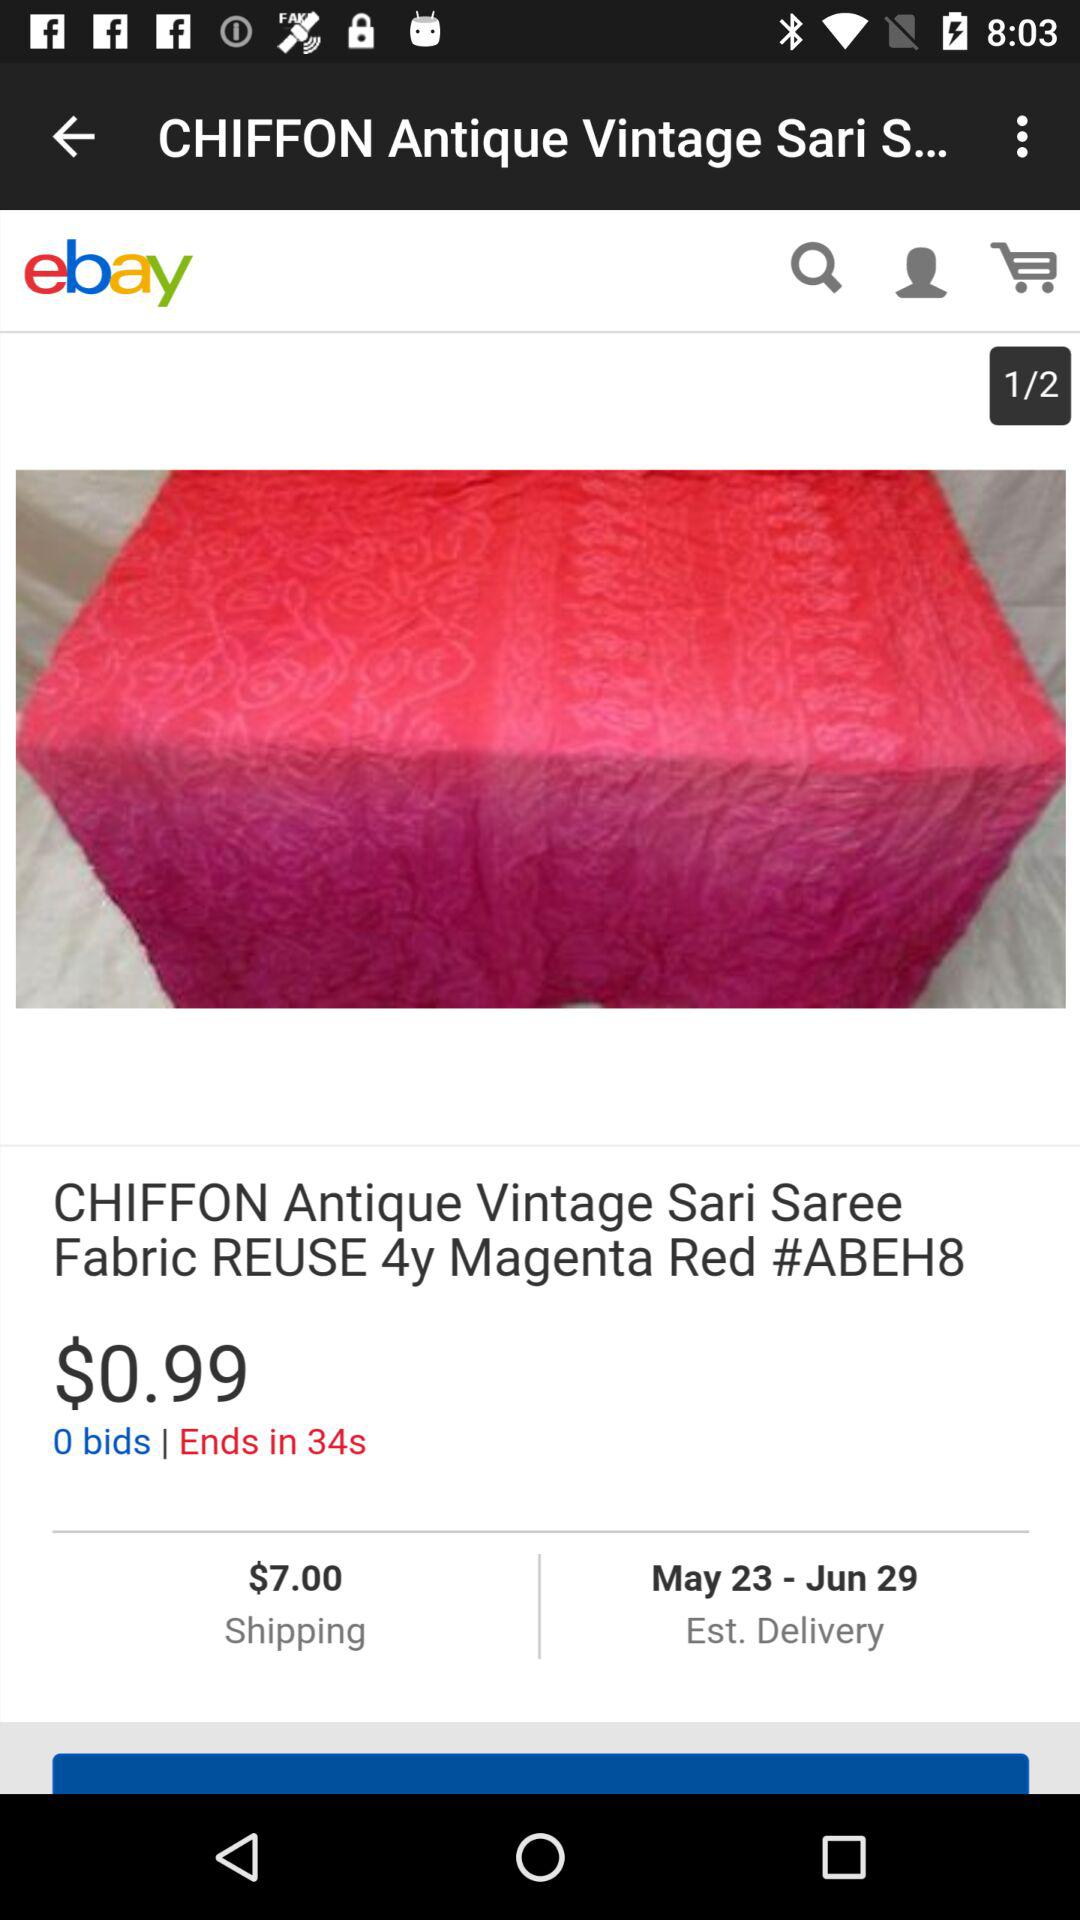What is the cost of the Chiffon Antique Vintage Saree fabric? The cost of the Chiffon Antique Vintage Saree fabric is $0.99. 